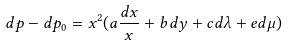<formula> <loc_0><loc_0><loc_500><loc_500>d p - d p _ { 0 } = x ^ { 2 } ( a \frac { d x } x + b d y + c d \lambda + e d \mu )</formula> 